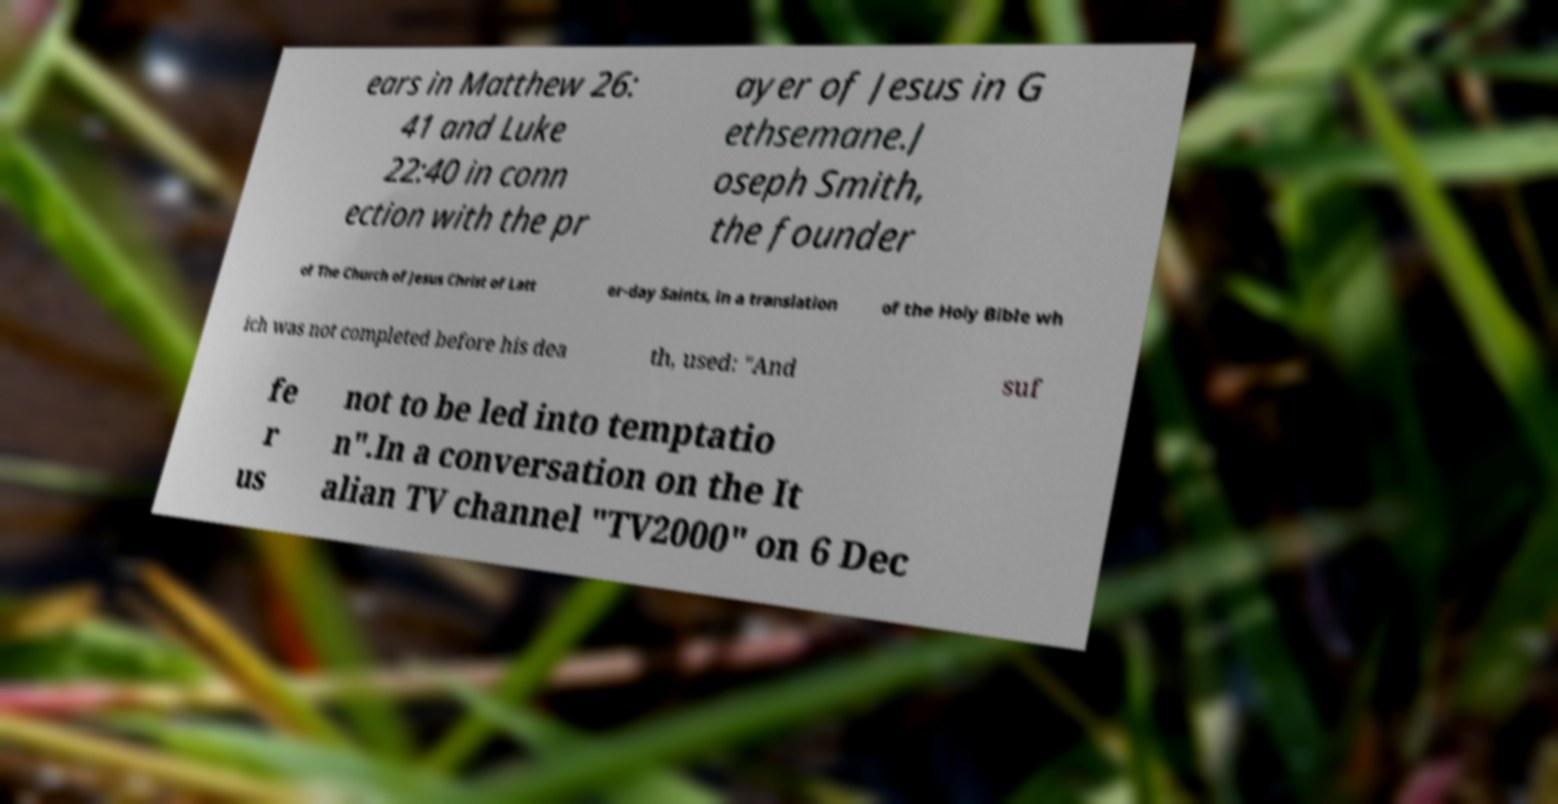I need the written content from this picture converted into text. Can you do that? ears in Matthew 26: 41 and Luke 22:40 in conn ection with the pr ayer of Jesus in G ethsemane.J oseph Smith, the founder of The Church of Jesus Christ of Latt er-day Saints, in a translation of the Holy Bible wh ich was not completed before his dea th, used: "And suf fe r us not to be led into temptatio n".In a conversation on the It alian TV channel "TV2000" on 6 Dec 